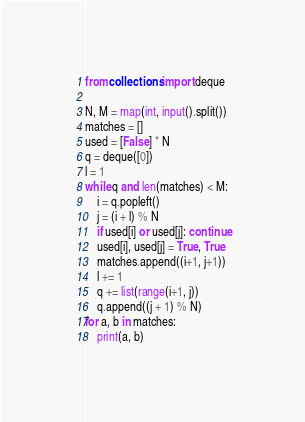Convert code to text. <code><loc_0><loc_0><loc_500><loc_500><_Python_>from collections import deque

N, M = map(int, input().split())
matches = []
used = [False] * N
q = deque([0])
l = 1
while q and len(matches) < M:
    i = q.popleft()
    j = (i + l) % N
    if used[i] or used[j]: continue
    used[i], used[j] = True, True
    matches.append((i+1, j+1))
    l += 1
    q += list(range(i+1, j))
    q.append((j + 1) % N)
for a, b in matches:
    print(a, b)</code> 